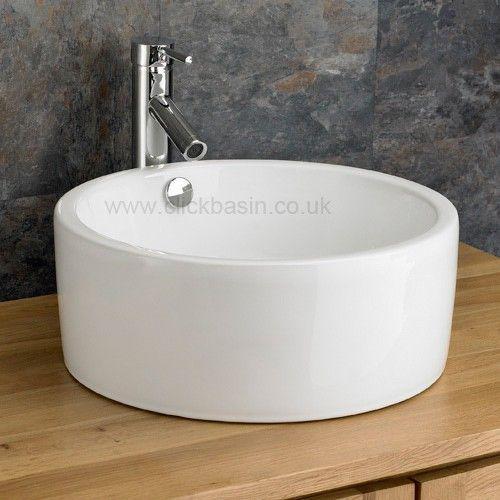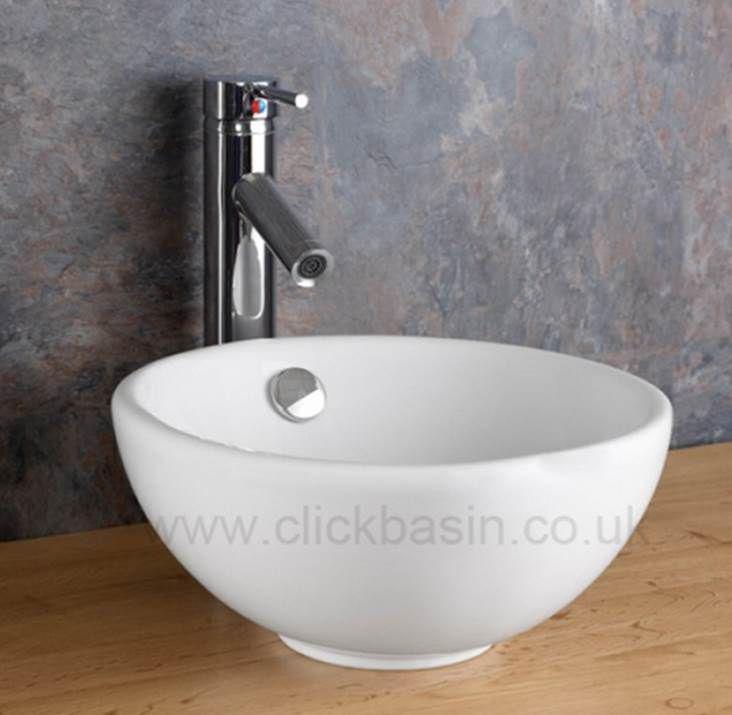The first image is the image on the left, the second image is the image on the right. Given the left and right images, does the statement "At least one of the sinks depicted has lever handles flanking the faucet." hold true? Answer yes or no. No. The first image is the image on the left, the second image is the image on the right. Analyze the images presented: Is the assertion "All sink faucets are a vertical chrome pipe with a horizontal piece extending over the sink bowl." valid? Answer yes or no. Yes. 